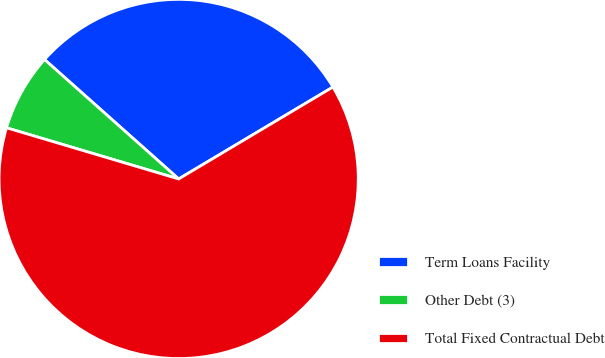Convert chart to OTSL. <chart><loc_0><loc_0><loc_500><loc_500><pie_chart><fcel>Term Loans Facility<fcel>Other Debt (3)<fcel>Total Fixed Contractual Debt<nl><fcel>29.87%<fcel>6.98%<fcel>63.15%<nl></chart> 